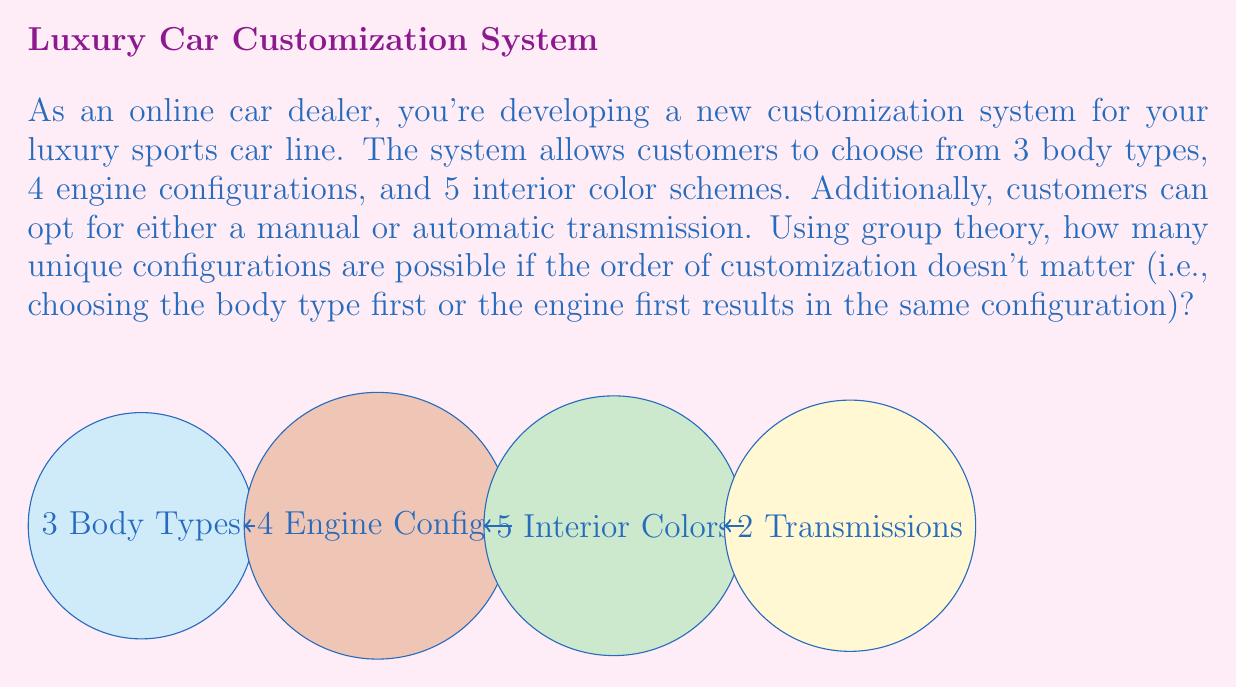Solve this math problem. To solve this problem using group theory, we can consider the customization options as a direct product of cyclic groups. Each customization option forms a cyclic group, and the total number of configurations is the order of the direct product of these groups.

Let's break it down step-by-step:

1) Body types: This forms a cyclic group of order 3, denoted as $C_3$
2) Engine configurations: This forms a cyclic group of order 4, denoted as $C_4$
3) Interior color schemes: This forms a cyclic group of order 5, denoted as $C_5$
4) Transmission options: This forms a cyclic group of order 2, denoted as $C_2$

The group of all possible configurations is the direct product of these cyclic groups:

$$G = C_3 \times C_4 \times C_5 \times C_2$$

In group theory, the order of a direct product of groups is the product of the orders of the individual groups. Therefore, the order of G is:

$$|G| = |C_3| \cdot |C_4| \cdot |C_5| \cdot |C_2|$$

Substituting the values:

$$|G| = 3 \cdot 4 \cdot 5 \cdot 2$$

$$|G| = 120$$

This result gives us the total number of unique configurations possible in our customization system.

Note: The order in which customizations are chosen doesn't matter because the direct product operation is commutative, which aligns with the given condition in the question.
Answer: 120 unique configurations 